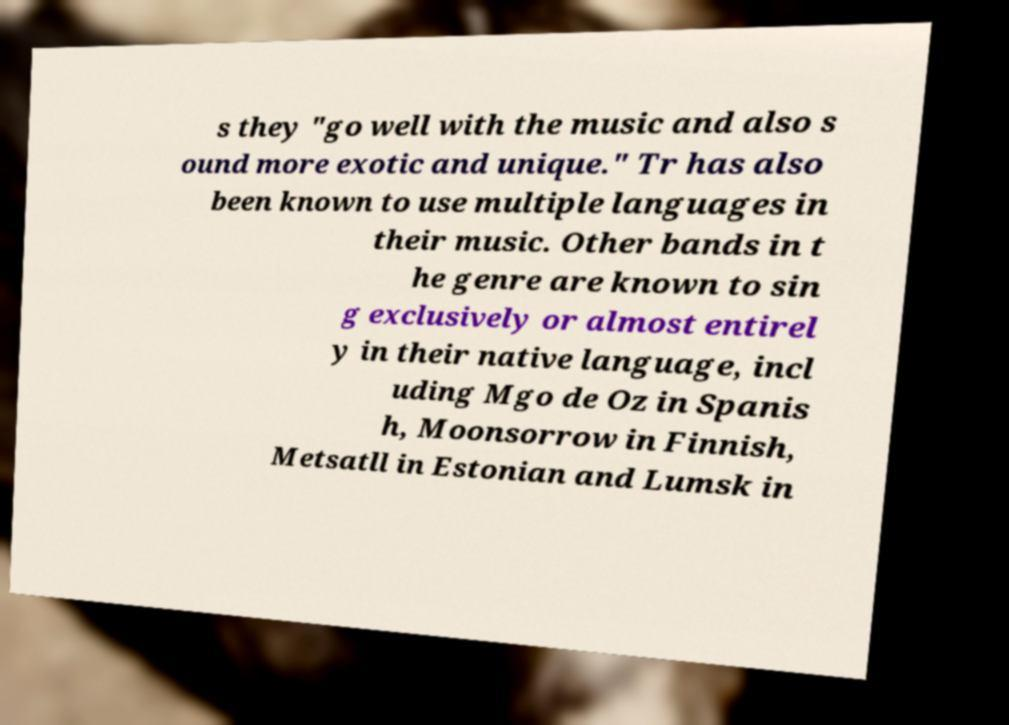What messages or text are displayed in this image? I need them in a readable, typed format. s they "go well with the music and also s ound more exotic and unique." Tr has also been known to use multiple languages in their music. Other bands in t he genre are known to sin g exclusively or almost entirel y in their native language, incl uding Mgo de Oz in Spanis h, Moonsorrow in Finnish, Metsatll in Estonian and Lumsk in 